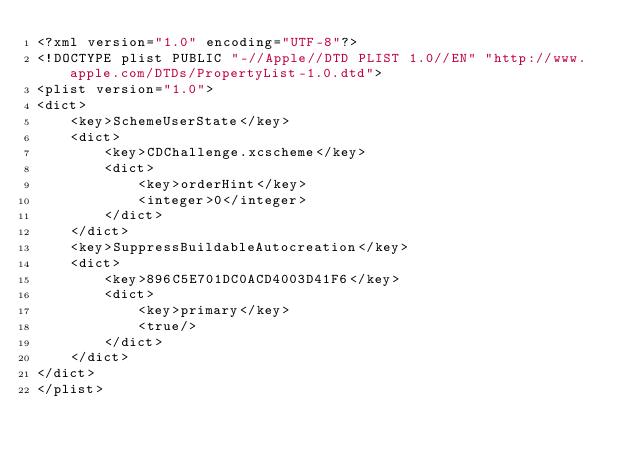<code> <loc_0><loc_0><loc_500><loc_500><_XML_><?xml version="1.0" encoding="UTF-8"?>
<!DOCTYPE plist PUBLIC "-//Apple//DTD PLIST 1.0//EN" "http://www.apple.com/DTDs/PropertyList-1.0.dtd">
<plist version="1.0">
<dict>
	<key>SchemeUserState</key>
	<dict>
		<key>CDChallenge.xcscheme</key>
		<dict>
			<key>orderHint</key>
			<integer>0</integer>
		</dict>
	</dict>
	<key>SuppressBuildableAutocreation</key>
	<dict>
		<key>896C5E701DC0ACD4003D41F6</key>
		<dict>
			<key>primary</key>
			<true/>
		</dict>
	</dict>
</dict>
</plist>
</code> 